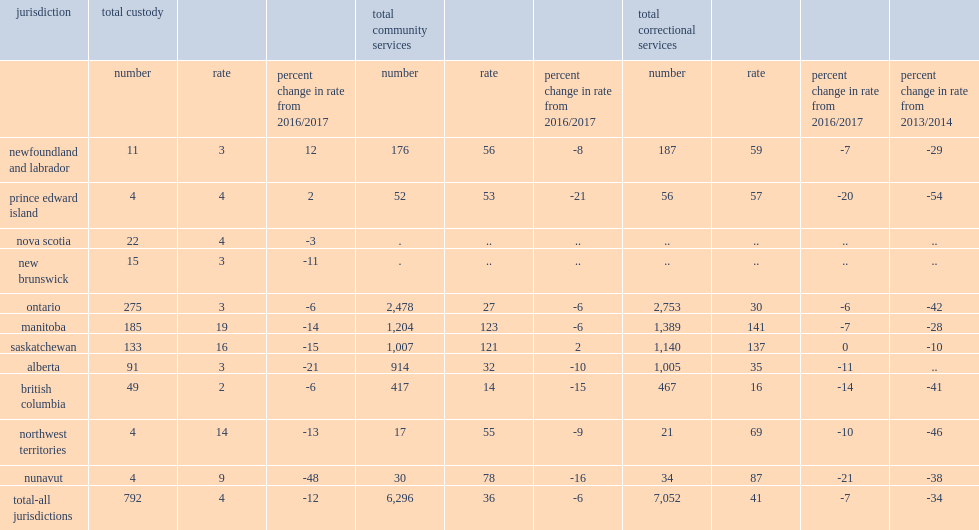How many youth supervised in correctional services in all jurisdictions were there on average per day in 2017/2018? 7052.0. How many youth per 10,000 population were there supervised in correctional services in all jurisdictions on average per day in 2017/2018? 41.0. What was the declines in the rate of youth supervised in correctional services in all jurisdictions from 2016/2017? 7. What was the declines in the rate of youth supervised in correctional services in all jurisdictions from 2013/2014? 34. What was the declines in the rate of youth supervised in correctional services in all jurisdictions in british columbia from 2016/2017? 14. What was the declines in the rate of youth supervised in correctional services in all jurisdictions in alberta from 2016/2017? 11. What was the declines in the rate of youth supervised in correctional services in all jurisdictions in nunavut from 2016/2017? 21. What was the proportion of youth correctional population in the nine reporting jurisdictions were under community supervision on an average day in 2017/2018? 0.892796. How many youth were there in custody on average per day in the 11 reporting jurisdictions in 2017/2018? 792.0. How many youth per 10,000 population were there in custody on average per day in the 11 reporting jurisdictions in 2017/2018? 4.0. What was the declines in the rate of youth in custody on average per day in the 11 reporting jurisdictions from 2016/2017? 12. How many jurisdictions in which the youth incarceration rate fell from 2016/2017? 9. How much did the youth incarceration rate decrease in alberta from 2016/2017? 21. How much did the youth incarceration rate decrease in saskatchewan from 2016/2017? 15. How much did the youth incarceration rate decrease in manitoba from 2016/2017? 14. How much did the youth incarceration rate decrease in new brunswick from 2016/2017? 11. How much did the youth incarceration rate decrease in nunavut from 2016/2017? 48. How much did the youth incarceration rate decrease in northwest territories from 2016/2017? 13. How many youth per 10,000 population were in custody in manitoba in 2017/2018? 19.0. How many youth per 10,000 population were in custody in saskatchewan in 2017/2018? 16.0. How many youth per 10,000 population were in custody in northwest territories in 2017/2018? 14.0. How many youth per 10,000 population were in custody in nunavut in 2017/2018? 9.0. 